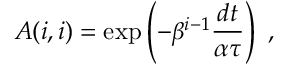<formula> <loc_0><loc_0><loc_500><loc_500>A ( i , i ) = \exp \left ( - \beta ^ { i - 1 } \frac { d t } { \alpha \tau } \right ) \ ,</formula> 